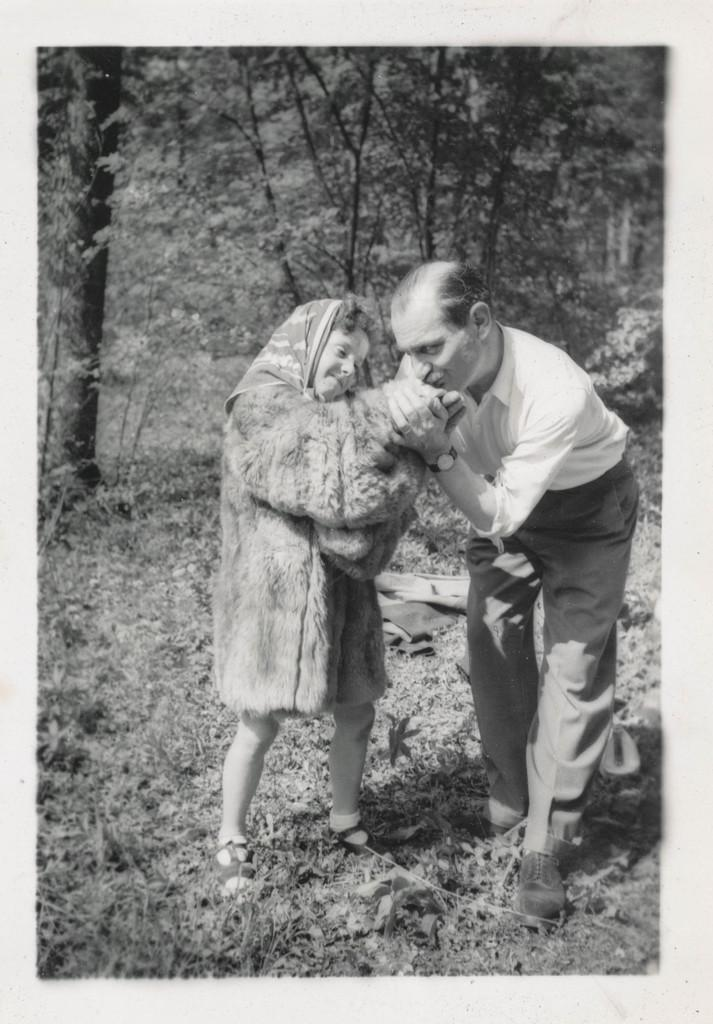Who are the people in the image? There is a small girl and a man in the image. What is the color scheme of the image? The image is black and white. What can be seen in the background of the image? There are trees in the background of the image. What type of wire is the girl holding in the image? There is no wire present in the image. Is the man in the image floating in space? The image does not depict the man floating in space; it is a regular image with a man and a small girl. 